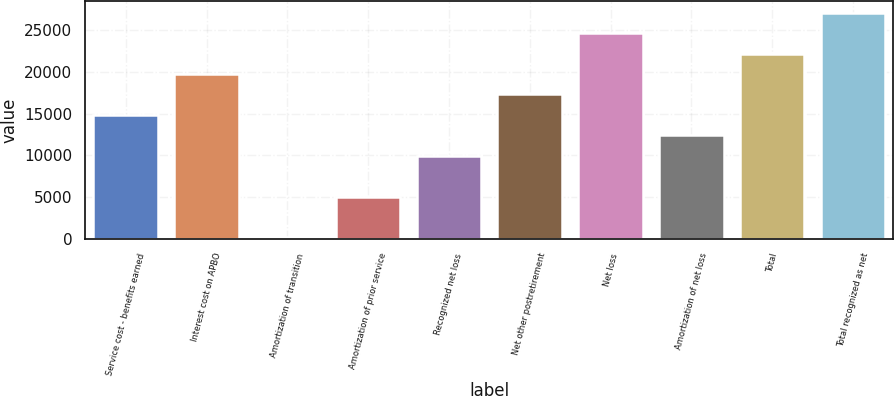Convert chart to OTSL. <chart><loc_0><loc_0><loc_500><loc_500><bar_chart><fcel>Service cost - benefits earned<fcel>Interest cost on APBO<fcel>Amortization of transition<fcel>Amortization of prior service<fcel>Recognized net loss<fcel>Net other postretirement<fcel>Net loss<fcel>Amortization of net loss<fcel>Total<fcel>Total recognized as net<nl><fcel>14863.6<fcel>19755.8<fcel>187<fcel>5079.2<fcel>9971.4<fcel>17309.7<fcel>24648<fcel>12417.5<fcel>22201.9<fcel>27094.1<nl></chart> 